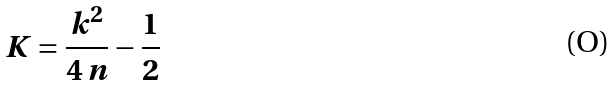Convert formula to latex. <formula><loc_0><loc_0><loc_500><loc_500>K = \frac { k ^ { 2 } } { 4 \, n } - \frac { 1 } { 2 }</formula> 